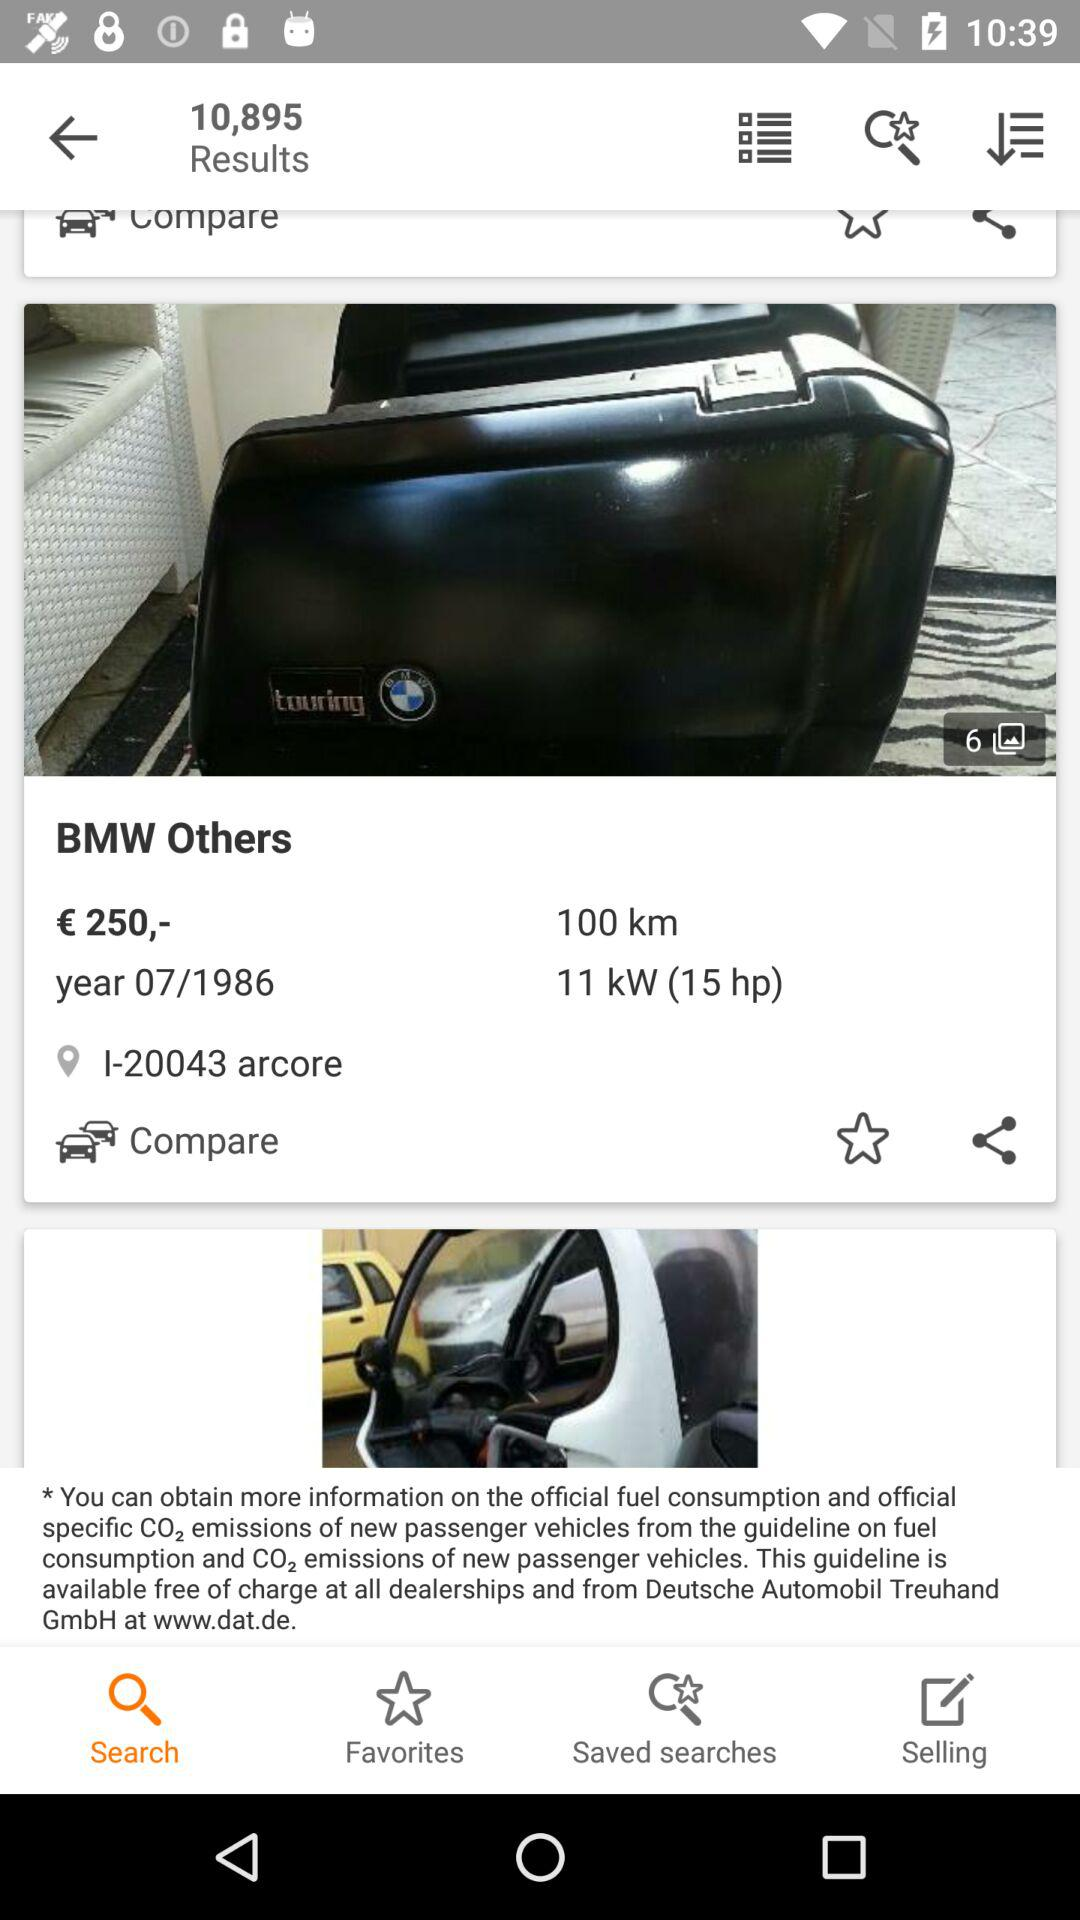How many results are there? There are 10,895 results. 